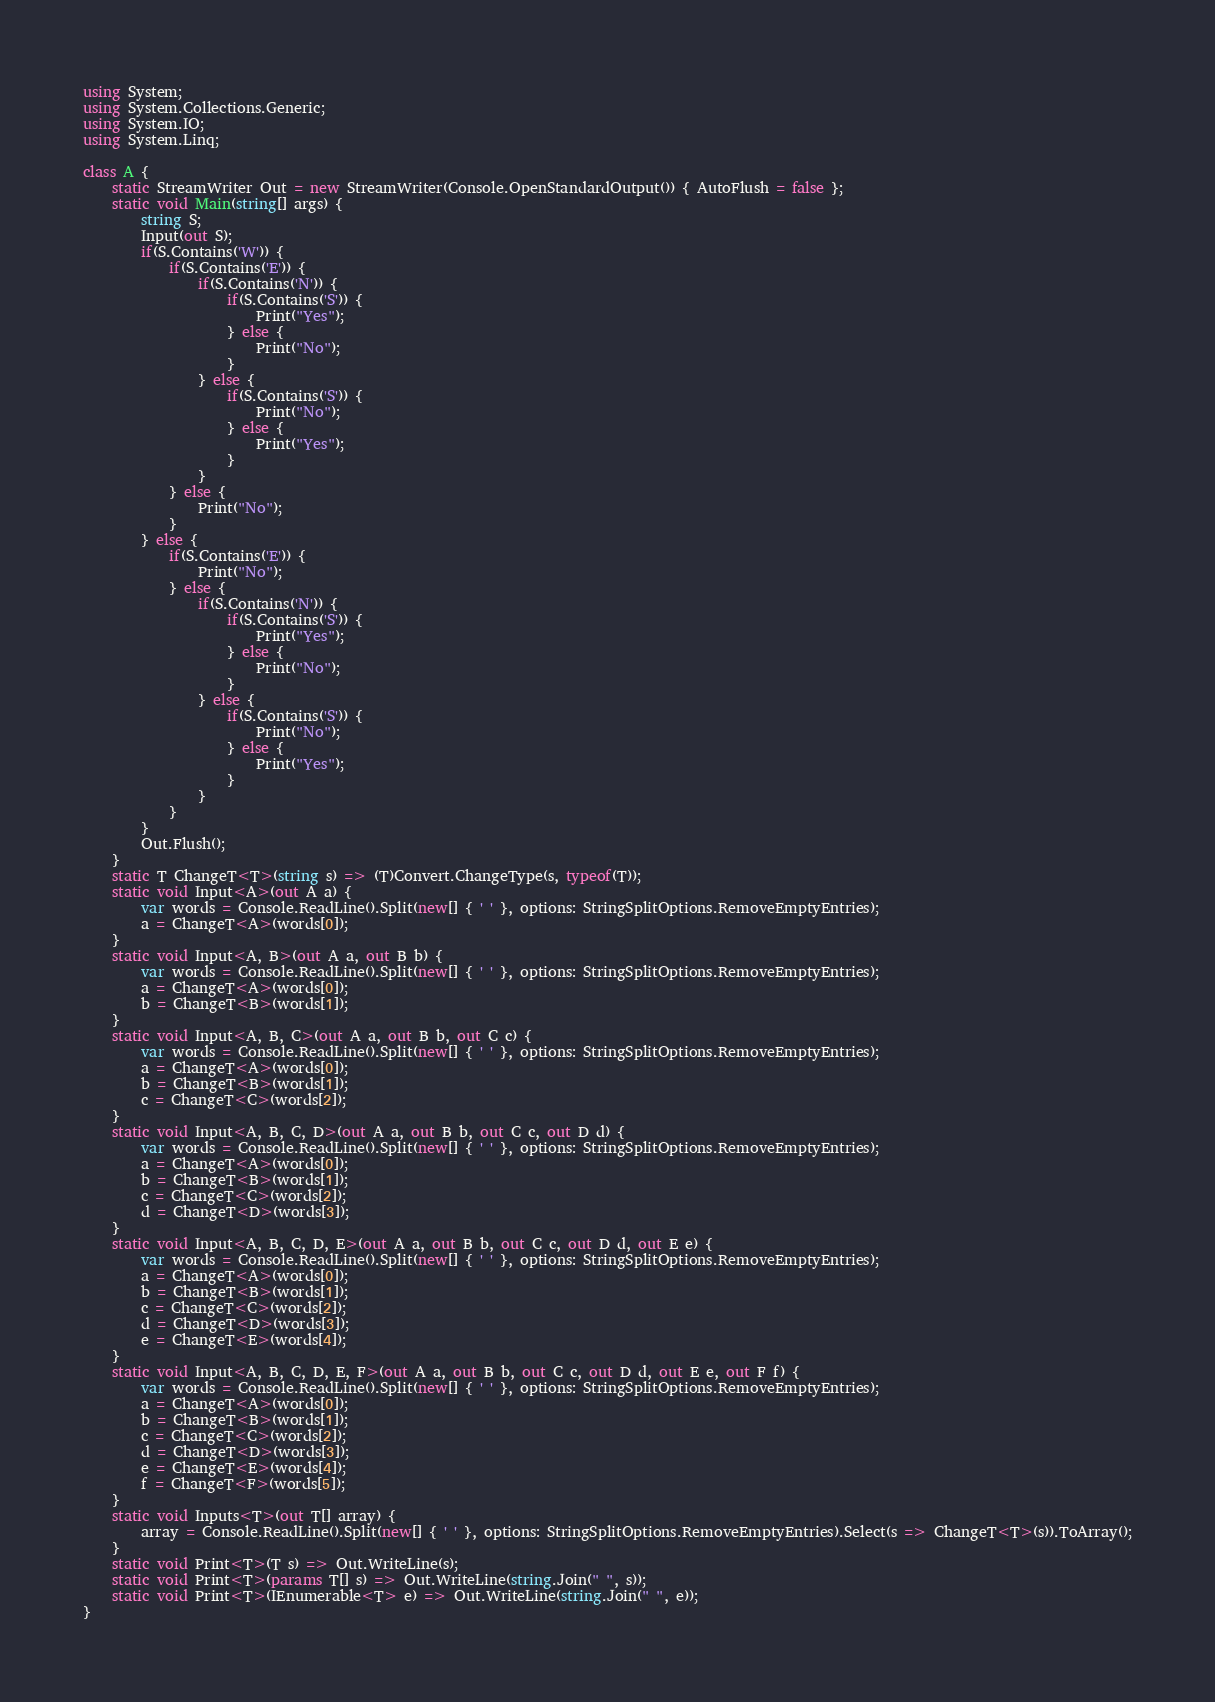<code> <loc_0><loc_0><loc_500><loc_500><_C#_>using System;
using System.Collections.Generic;
using System.IO;
using System.Linq;

class A {
    static StreamWriter Out = new StreamWriter(Console.OpenStandardOutput()) { AutoFlush = false };
    static void Main(string[] args) {
        string S;
        Input(out S);
        if(S.Contains('W')) {
            if(S.Contains('E')) {
                if(S.Contains('N')) {
                    if(S.Contains('S')) {
                        Print("Yes");
                    } else {
                        Print("No");
                    }
                } else {
                    if(S.Contains('S')) {
                        Print("No");
                    } else {
                        Print("Yes");
                    }
                }
            } else {
                Print("No");
            }
        } else {
            if(S.Contains('E')) {
                Print("No");
            } else {
                if(S.Contains('N')) {
                    if(S.Contains('S')) {
                        Print("Yes");
                    } else {
                        Print("No");
                    }
                } else {
                    if(S.Contains('S')) {
                        Print("No");
                    } else {
                        Print("Yes");
                    }
                }
            }
        }
        Out.Flush();
    }
    static T ChangeT<T>(string s) => (T)Convert.ChangeType(s, typeof(T));
    static void Input<A>(out A a) {
        var words = Console.ReadLine().Split(new[] { ' ' }, options: StringSplitOptions.RemoveEmptyEntries);
        a = ChangeT<A>(words[0]);
    }
    static void Input<A, B>(out A a, out B b) {
        var words = Console.ReadLine().Split(new[] { ' ' }, options: StringSplitOptions.RemoveEmptyEntries);
        a = ChangeT<A>(words[0]);
        b = ChangeT<B>(words[1]);
    }
    static void Input<A, B, C>(out A a, out B b, out C c) {
        var words = Console.ReadLine().Split(new[] { ' ' }, options: StringSplitOptions.RemoveEmptyEntries);
        a = ChangeT<A>(words[0]);
        b = ChangeT<B>(words[1]);
        c = ChangeT<C>(words[2]);
    }
    static void Input<A, B, C, D>(out A a, out B b, out C c, out D d) {
        var words = Console.ReadLine().Split(new[] { ' ' }, options: StringSplitOptions.RemoveEmptyEntries);
        a = ChangeT<A>(words[0]);
        b = ChangeT<B>(words[1]);
        c = ChangeT<C>(words[2]);
        d = ChangeT<D>(words[3]);
    }
    static void Input<A, B, C, D, E>(out A a, out B b, out C c, out D d, out E e) {
        var words = Console.ReadLine().Split(new[] { ' ' }, options: StringSplitOptions.RemoveEmptyEntries);
        a = ChangeT<A>(words[0]);
        b = ChangeT<B>(words[1]);
        c = ChangeT<C>(words[2]);
        d = ChangeT<D>(words[3]);
        e = ChangeT<E>(words[4]);
    }
    static void Input<A, B, C, D, E, F>(out A a, out B b, out C c, out D d, out E e, out F f) {
        var words = Console.ReadLine().Split(new[] { ' ' }, options: StringSplitOptions.RemoveEmptyEntries);
        a = ChangeT<A>(words[0]);
        b = ChangeT<B>(words[1]);
        c = ChangeT<C>(words[2]);
        d = ChangeT<D>(words[3]);
        e = ChangeT<E>(words[4]);
        f = ChangeT<F>(words[5]);
    }
    static void Inputs<T>(out T[] array) {
        array = Console.ReadLine().Split(new[] { ' ' }, options: StringSplitOptions.RemoveEmptyEntries).Select(s => ChangeT<T>(s)).ToArray();
    }
    static void Print<T>(T s) => Out.WriteLine(s);
    static void Print<T>(params T[] s) => Out.WriteLine(string.Join(" ", s));
    static void Print<T>(IEnumerable<T> e) => Out.WriteLine(string.Join(" ", e));
}</code> 